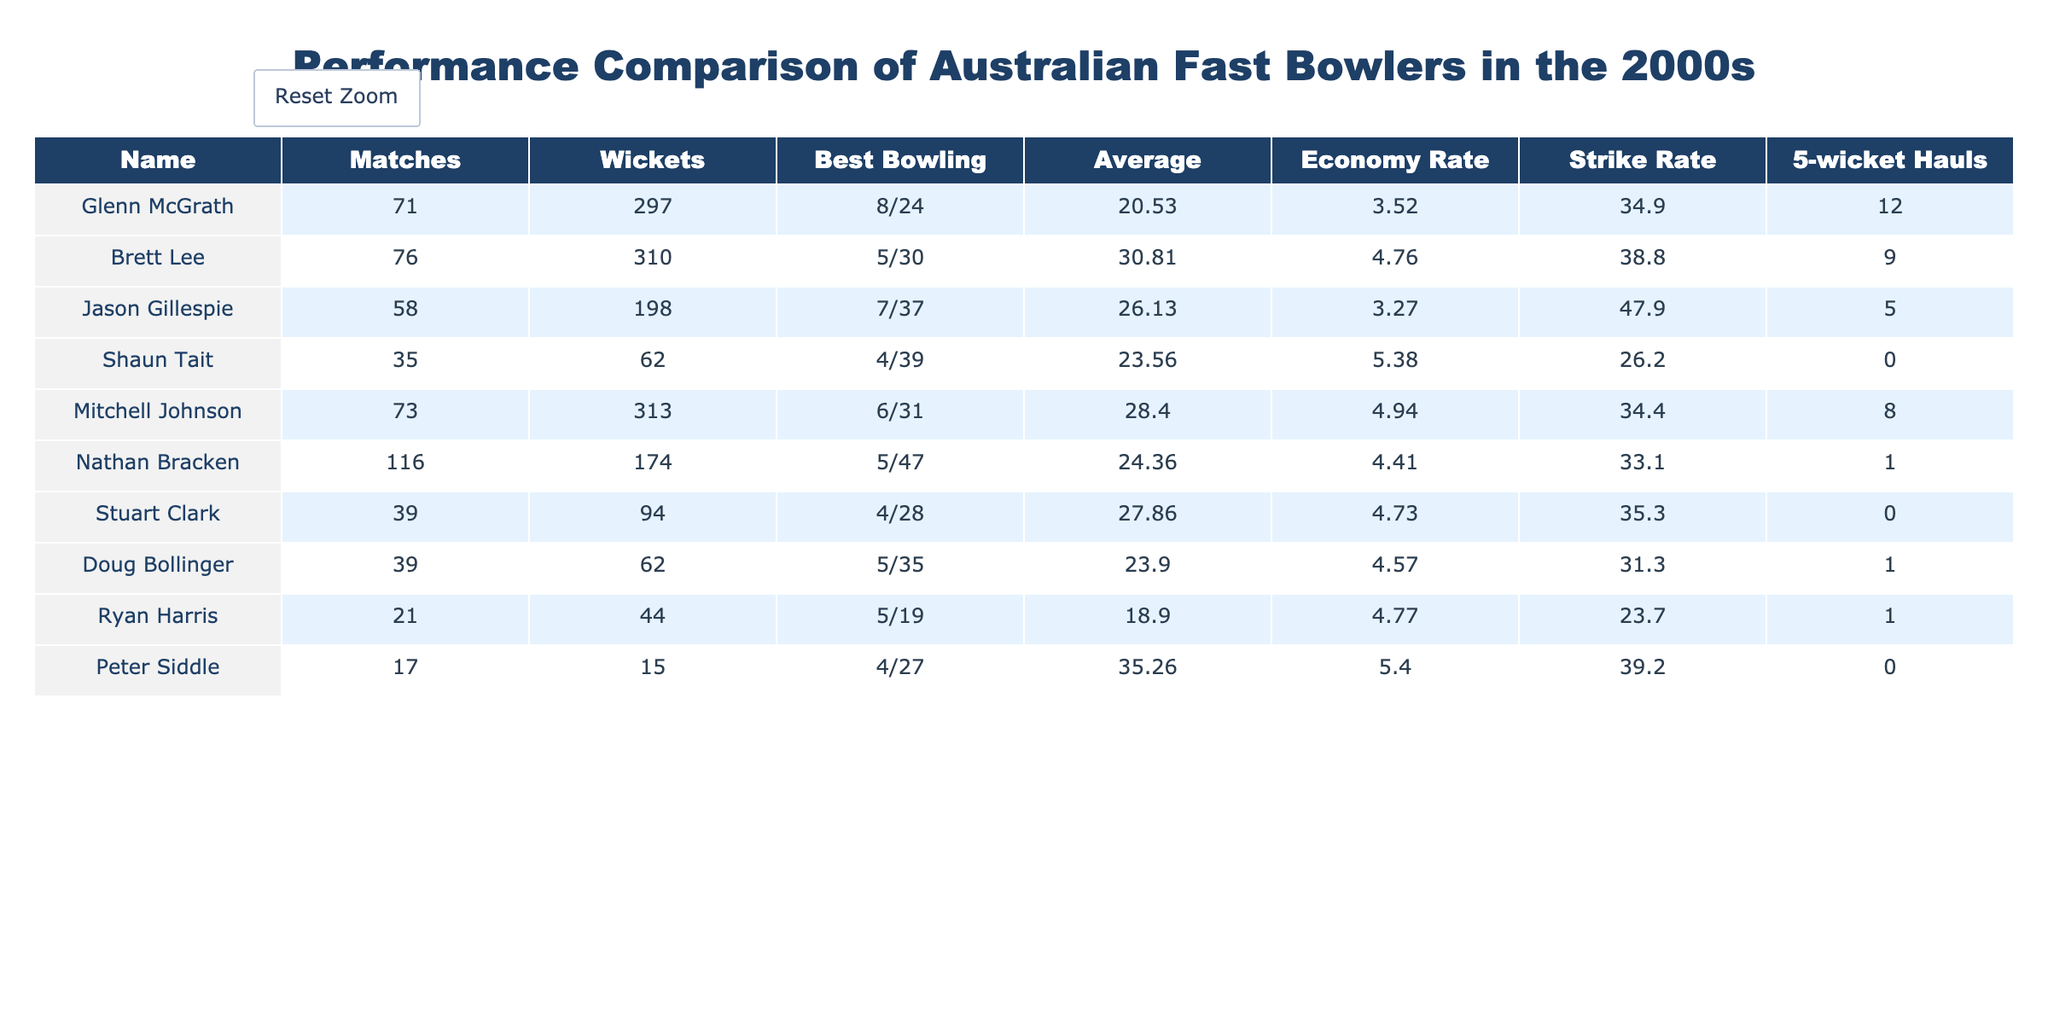What is the highest number of wickets taken by a bowler in this table? By looking at the "Wickets" column, Glenn McGrath has taken 297 wickets, which is greater than any other bowler listed. The next highest is Brett Lee with 310 wickets, but we notice he has 310, which is still higher
Answer: 310 Which bowler has the best bowling average among those listed? To find the best average, we compare the "Average" column values. The lower the average, the better the performance. Ryan Harris has an average of 18.90, which is the lowest in the table, indicating the best performance
Answer: 18.90 Did Shaun Tait take a 5-wicket haul in his career according to this table? Looking at the "5-wicket Hauls" column for Shaun Tait, we can see that it is marked as 0. This indicates that he has not achieved a 5-wicket haul during his matches
Answer: No Which fast bowler has the highest economy rate? We analyze the "Economy Rate" column to identify the bowler with the highest rate. The maximum value is 5.40, found next to Peter Siddle's name. This indicates he allows more runs per over than others
Answer: 5.40 What is the total number of wickets taken by the bowlers listed with more than 70 matches played? We first identify the bowlers who played more than 70 matches: Glenn McGrath, Brett Lee, and Mitchell Johnson. Their wickets are 297, 310, and 313 respectively. Adding these gives us 297 + 310 + 313 = 920 wickets
Answer: 920 Which bowler has the best strike rate, and what is that rate? We look through the "Strike Rate" column to determine the lowest strike rate, which indicates better performance. Shaun Tait has a strike rate of 26.2, the lowest in the table, signifying he took wickets more frequently than others
Answer: 26.2 Is it true that Nathan Bracken took at least one 5-wicket haul? We check Nathan Bracken's entry under the "5-wicket Hauls" column, which shows a value of 1. This tells us he has indeed taken at least one 5-wicket haul in his career
Answer: Yes What is the average bowling performance in terms of wickets taken for bowls with fewer than 30 matches? We gather only the bowlers with fewer than 30 matches: Peter Siddle with 15 and Ryan Harris with 21. They have taken 15 and 44 wickets respectively. Summing these gives us 15 + 44 = 59. Then, since there are 2 bowlers, the average is 59/2 = 29.5
Answer: 29.5 Which bowler had the best bowling figures in a match and what were those figures? We survey the "Best Bowling" column and find Glenn McGrath's figures of 8/24, which are better than any of the other bowlers. Thus, he holds the record for the best single-match performance
Answer: 8/24 